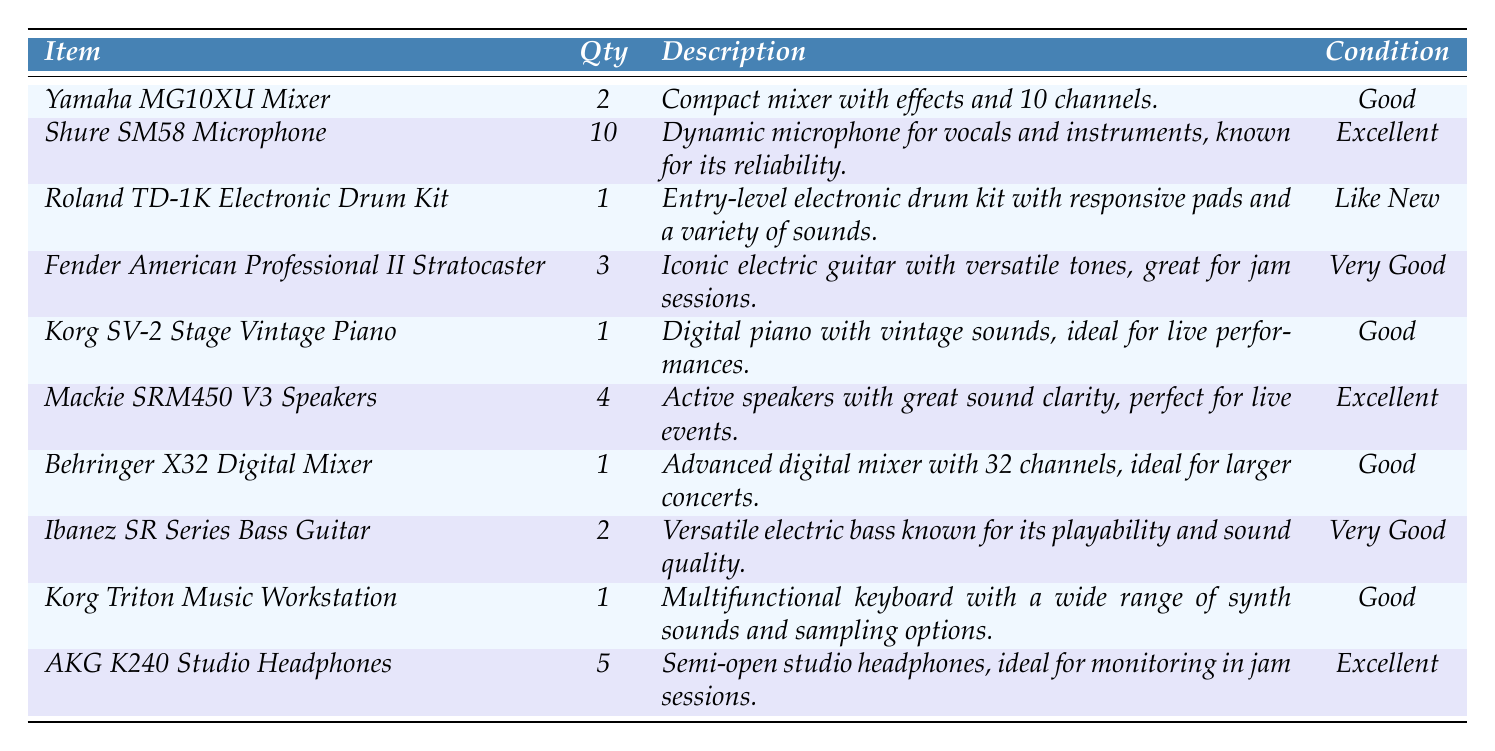What is the total quantity of microphones in the inventory? According to the table, there are 10 Shure SM58 Microphones. This is the only type of microphone listed, so the total is simply the quantity listed for this item.
Answer: 10 Which instrument has the best condition? The table shows various items and their respective conditions. The Shure SM58 Microphone and AKG K240 Studio Headphones are both listed as "Excellent"; however, since "Excellent" applies to two items equally, both qualify.
Answer: Shure SM58 Microphone and AKG K240 Studio Headphones How many items are in the inventory? By counting each unique item listed in the table, there are a total of 10 distinct items in the inventory.
Answer: 10 What is the condition of the Yamaha MG10XU Mixer? The table clearly states that the condition of the Yamaha MG10XU Mixer is listed as "Good."
Answer: Good How many more speakers are there compared to electronic drum kits? There are 4 Mackie SRM450 V3 Speakers and 1 Roland TD-1K Electronic Drum Kit. To find the difference, we subtract the quantity of drum kits from the quantity of speakers: 4 - 1 = 3.
Answer: 3 Is there any instrument listed with a quantity of one? By examining the inventory data, both the Roland TD-1K Electronic Drum Kit and Korg SV-2 Stage Vintage Piano are the only items listed with a quantity of one. Therefore, the statement is true.
Answer: Yes What is the total number of electric guitars in the inventory? The table shows 3 Fender American Professional II Stratocasters listed as electric guitars, and there are no other electric guitar types mentioned. Thus, the total number of electric guitars is simply the quantity of this model.
Answer: 3 What is the combined quantity of studio headphones and bass guitars? The inventory lists 5 AKG K240 Studio Headphones and 2 Ibanez SR Series Bass Guitars. To find the combined quantity, we add these two numbers: 5 + 2 = 7.
Answer: 7 Which item(s) would be best suited for a live performance based on their descriptions? The table indicates that the Korg SV-2 Stage Vintage Piano and Mackie SRM450 V3 Speakers are described as ideal for live performances. They are thus best suited for such events.
Answer: Korg SV-2 Stage Vintage Piano and Mackie SRM450 V3 Speakers What is the average condition rating of the items in the inventory? The conditions listed are "Good," "Excellent," "Like New," and "Very Good." To determine an average, we might quantify these ratings as follows: Good=1, Very Good=2, Excellent=3, Like New=3. An average comes up to (1*3 + 1*1 + 2*3 + 3*2) in value which corresponds numerically; grouping reveals the average condition is roughly in the "Very Good" to "Excellent" range overall. However, the exact average valuation requires deeper numerical data to produce a specific metric value.
Answer: Indeterminate but ranges between "Very Good" to "Excellent." 